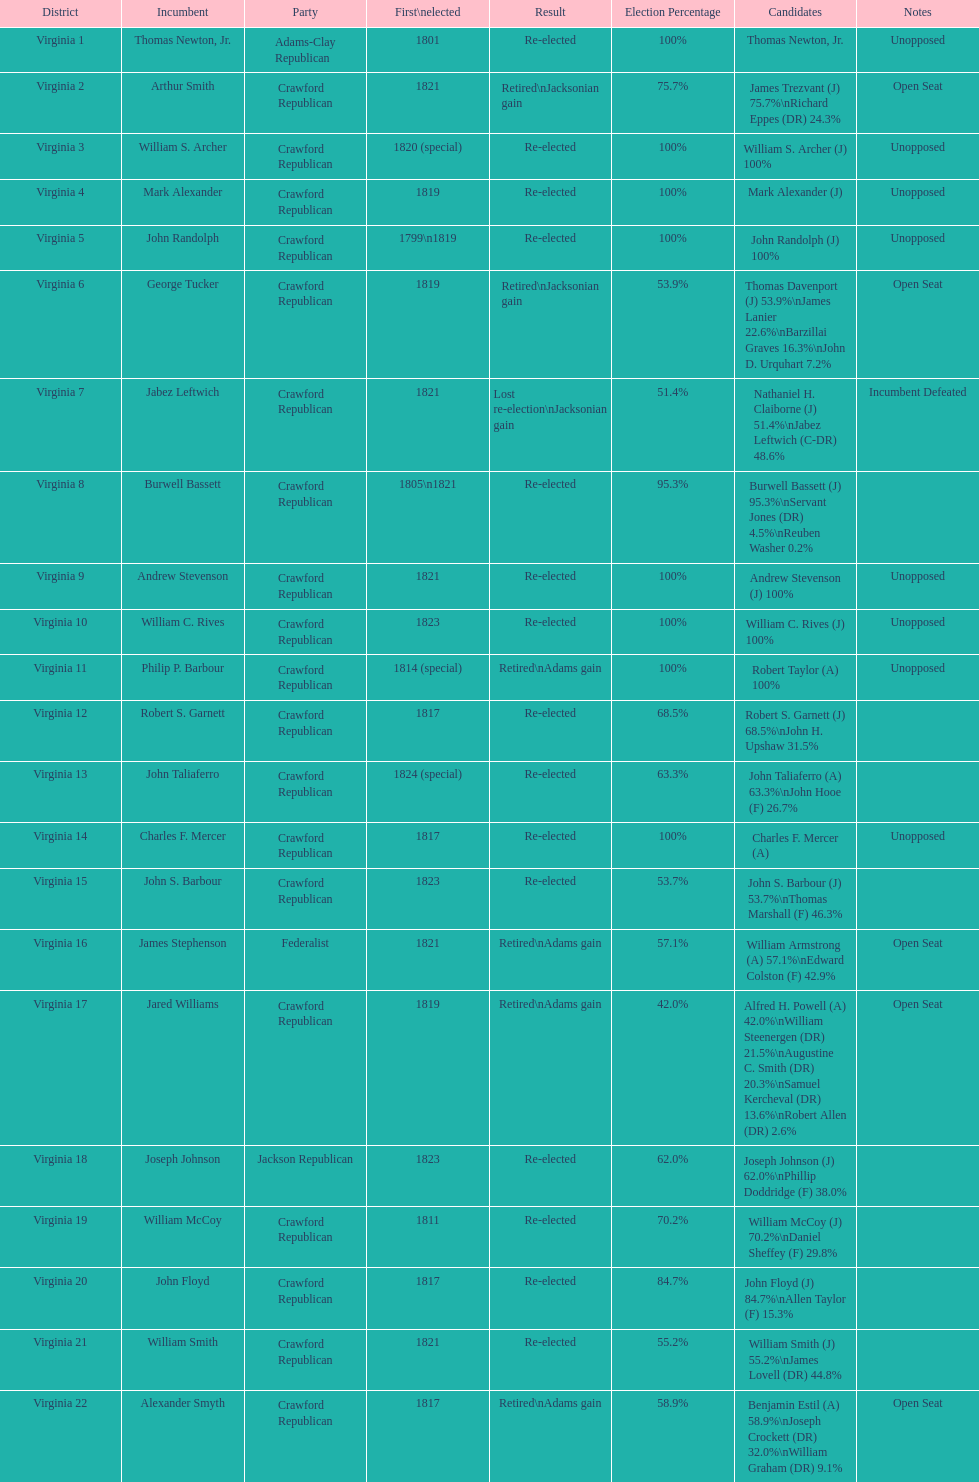Tell me the number of people first elected in 1817. 4. 